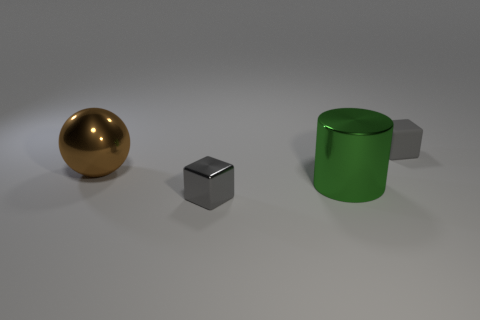There is a gray object on the left side of the gray cube behind the small shiny thing; how big is it?
Keep it short and to the point. Small. The matte object has what color?
Keep it short and to the point. Gray. There is a gray block behind the brown ball; how many small blocks are to the left of it?
Make the answer very short. 1. There is a gray cube on the right side of the gray metallic block; are there any green objects in front of it?
Your response must be concise. Yes. There is a big green metallic object; are there any green cylinders behind it?
Give a very brief answer. No. There is a matte thing behind the brown metal sphere; does it have the same shape as the tiny gray metal thing?
Provide a succinct answer. Yes. How many large brown objects have the same shape as the green thing?
Keep it short and to the point. 0. Is there a object made of the same material as the large brown sphere?
Make the answer very short. Yes. There is a block behind the tiny gray cube in front of the brown ball; what is it made of?
Your answer should be compact. Rubber. There is a gray block behind the brown metallic sphere; what size is it?
Your response must be concise. Small. 